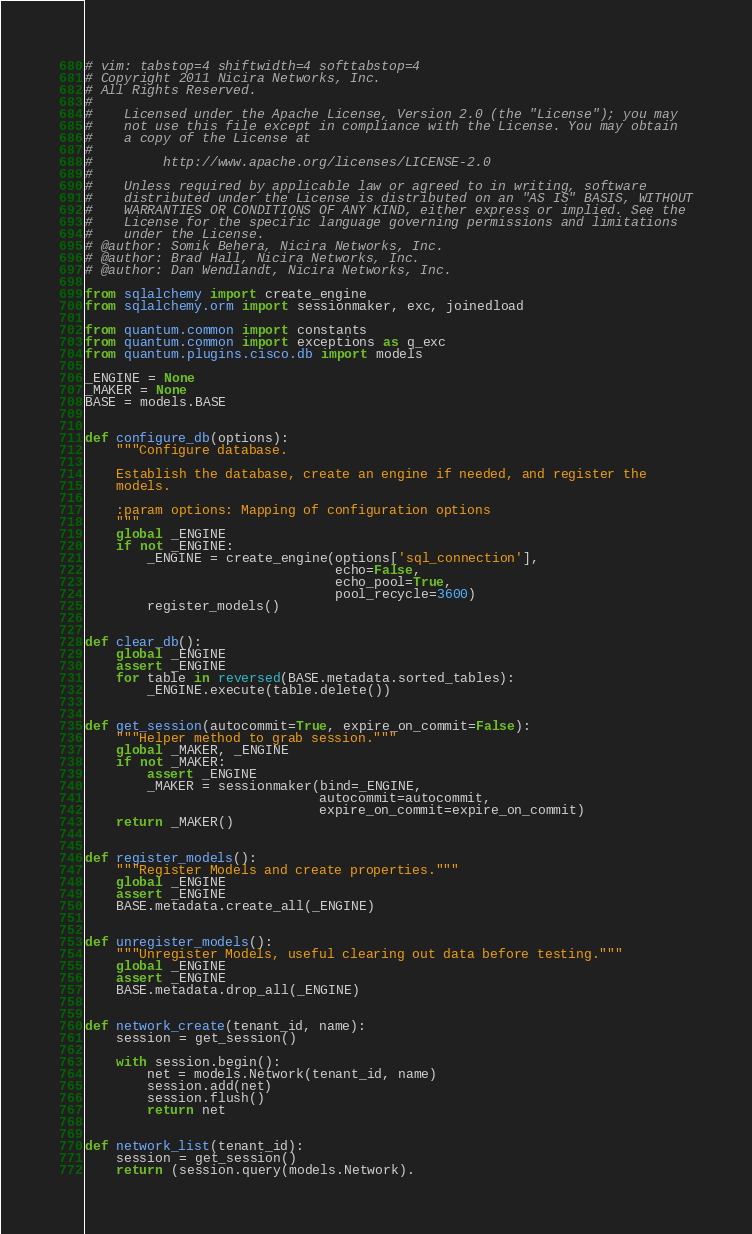Convert code to text. <code><loc_0><loc_0><loc_500><loc_500><_Python_># vim: tabstop=4 shiftwidth=4 softtabstop=4
# Copyright 2011 Nicira Networks, Inc.
# All Rights Reserved.
#
#    Licensed under the Apache License, Version 2.0 (the "License"); you may
#    not use this file except in compliance with the License. You may obtain
#    a copy of the License at
#
#         http://www.apache.org/licenses/LICENSE-2.0
#
#    Unless required by applicable law or agreed to in writing, software
#    distributed under the License is distributed on an "AS IS" BASIS, WITHOUT
#    WARRANTIES OR CONDITIONS OF ANY KIND, either express or implied. See the
#    License for the specific language governing permissions and limitations
#    under the License.
# @author: Somik Behera, Nicira Networks, Inc.
# @author: Brad Hall, Nicira Networks, Inc.
# @author: Dan Wendlandt, Nicira Networks, Inc.

from sqlalchemy import create_engine
from sqlalchemy.orm import sessionmaker, exc, joinedload

from quantum.common import constants
from quantum.common import exceptions as q_exc
from quantum.plugins.cisco.db import models

_ENGINE = None
_MAKER = None
BASE = models.BASE


def configure_db(options):
    """Configure database.

    Establish the database, create an engine if needed, and register the
    models.

    :param options: Mapping of configuration options
    """
    global _ENGINE
    if not _ENGINE:
        _ENGINE = create_engine(options['sql_connection'],
                                echo=False,
                                echo_pool=True,
                                pool_recycle=3600)
        register_models()


def clear_db():
    global _ENGINE
    assert _ENGINE
    for table in reversed(BASE.metadata.sorted_tables):
        _ENGINE.execute(table.delete())


def get_session(autocommit=True, expire_on_commit=False):
    """Helper method to grab session."""
    global _MAKER, _ENGINE
    if not _MAKER:
        assert _ENGINE
        _MAKER = sessionmaker(bind=_ENGINE,
                              autocommit=autocommit,
                              expire_on_commit=expire_on_commit)
    return _MAKER()


def register_models():
    """Register Models and create properties."""
    global _ENGINE
    assert _ENGINE
    BASE.metadata.create_all(_ENGINE)


def unregister_models():
    """Unregister Models, useful clearing out data before testing."""
    global _ENGINE
    assert _ENGINE
    BASE.metadata.drop_all(_ENGINE)


def network_create(tenant_id, name):
    session = get_session()

    with session.begin():
        net = models.Network(tenant_id, name)
        session.add(net)
        session.flush()
        return net


def network_list(tenant_id):
    session = get_session()
    return (session.query(models.Network).</code> 